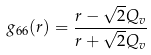<formula> <loc_0><loc_0><loc_500><loc_500>g _ { 6 6 } ( r ) = \frac { r - \sqrt { 2 } Q _ { v } } { r + \sqrt { 2 } Q _ { v } }</formula> 